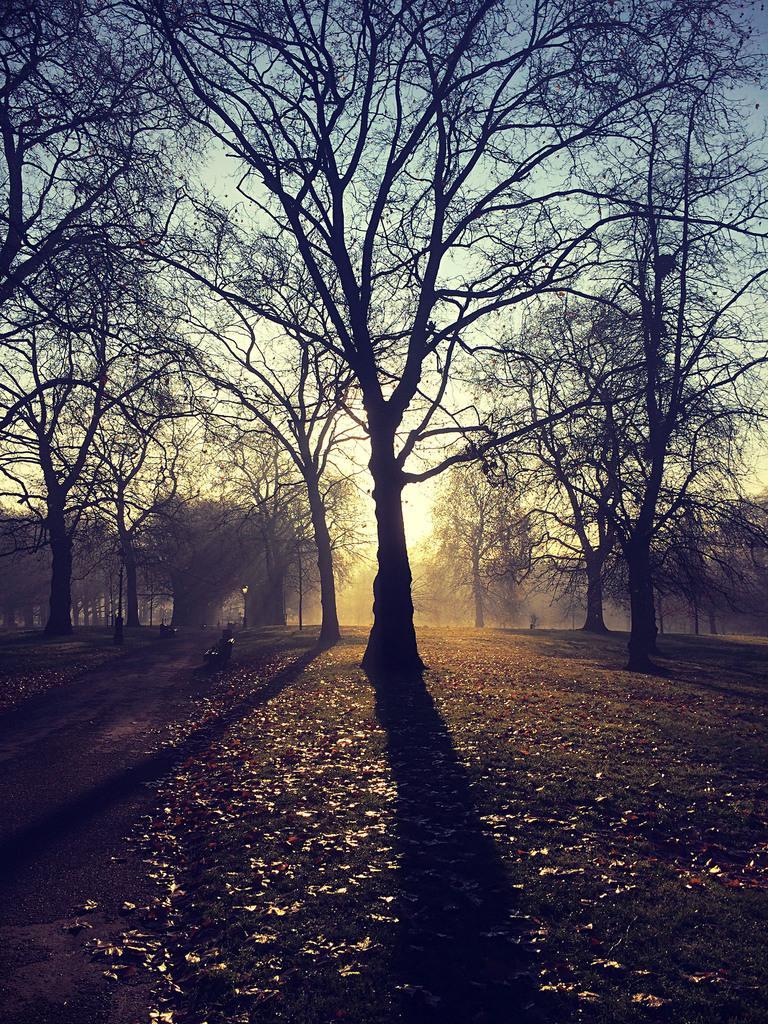Can you describe this image briefly? In this image I can see trees and the sky and sun light. 